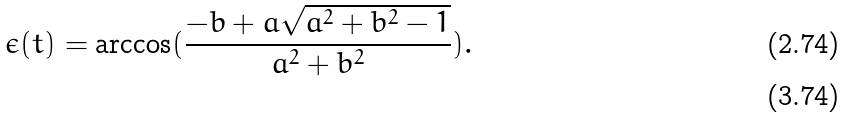Convert formula to latex. <formula><loc_0><loc_0><loc_500><loc_500>\epsilon ( t ) = \arccos ( \frac { - b + a \sqrt { a ^ { 2 } + b ^ { 2 } - 1 } } { a ^ { 2 } + b ^ { 2 } } ) . \\</formula> 